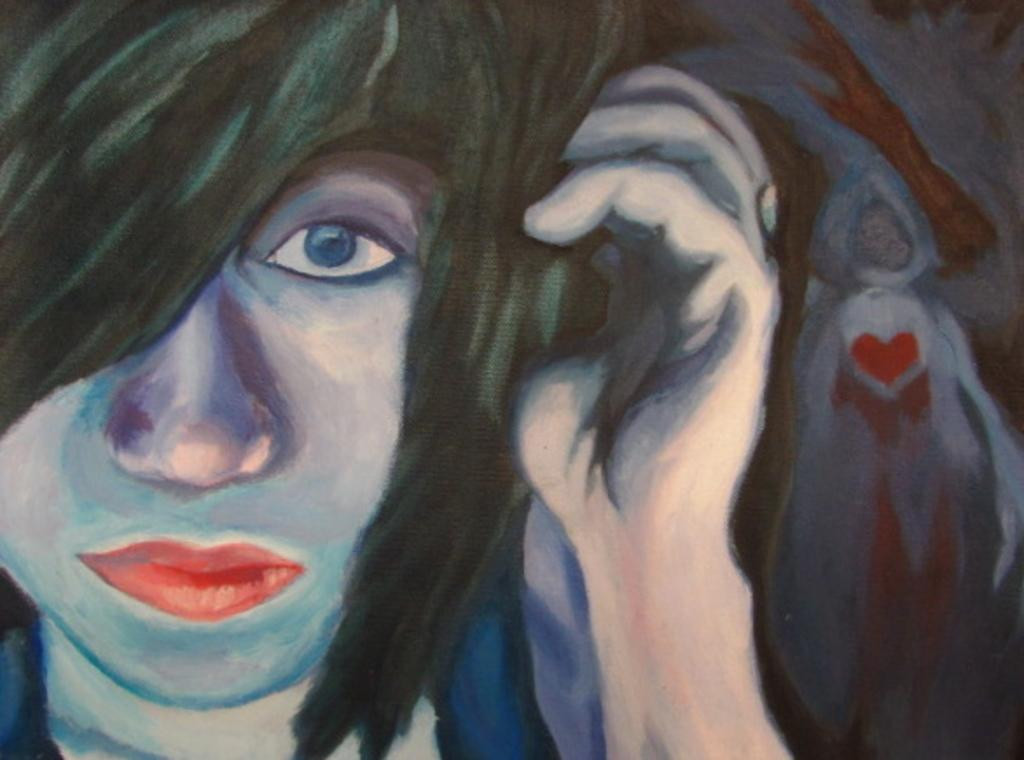What type of artwork is shown in the image? The image is a painting. What subject is depicted in the painting? The painting depicts a woman. What type of liquid is being delivered in the painting? There is no liquid or delivery depicted in the painting; it features a woman. What toys can be seen in the hands of the woman in the painting? There are no toys present in the painting; it depicts a woman without any toys. 